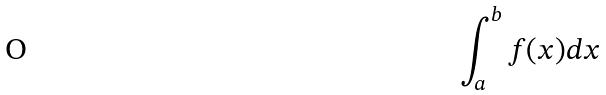Convert formula to latex. <formula><loc_0><loc_0><loc_500><loc_500>\int _ { a } ^ { b } f ( x ) d x</formula> 